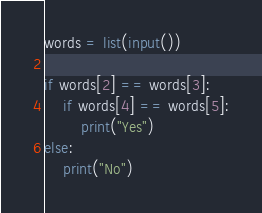<code> <loc_0><loc_0><loc_500><loc_500><_Python_>words = list(input())

if words[2] == words[3]:
    if words[4] == words[5]:
        print("Yes")
else:
    print("No")
</code> 